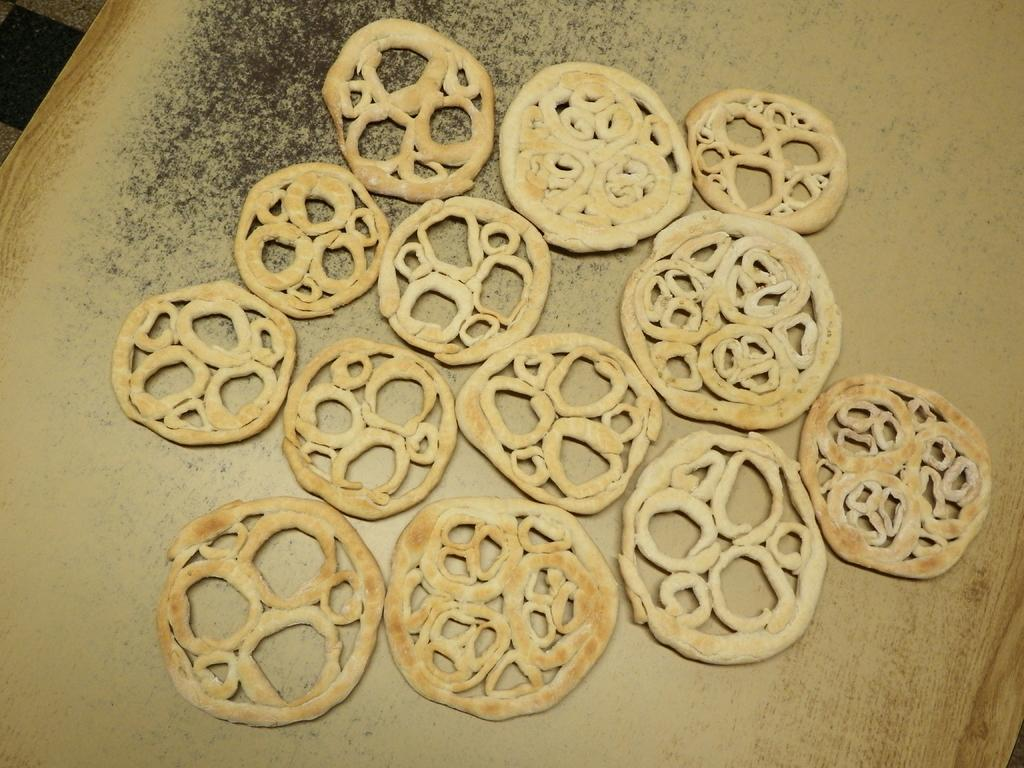What is the main object in the center of the image? There is a table in the center of the image. What can be found on the table? There are food items on the table. What type of beast can be seen playing the guitar in the image? There is no beast or guitar present in the image; it only features a table with food items. 